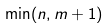Convert formula to latex. <formula><loc_0><loc_0><loc_500><loc_500>\min ( n , m + 1 )</formula> 